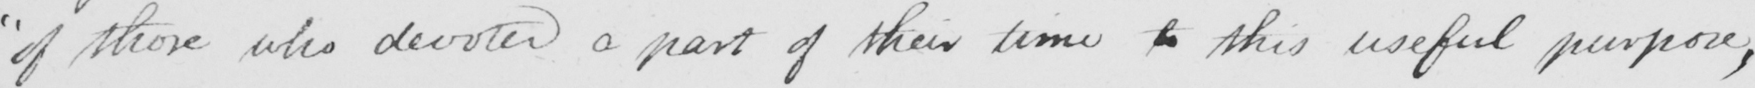What does this handwritten line say? "of those who devoted a part of their time to this useful purpose, 